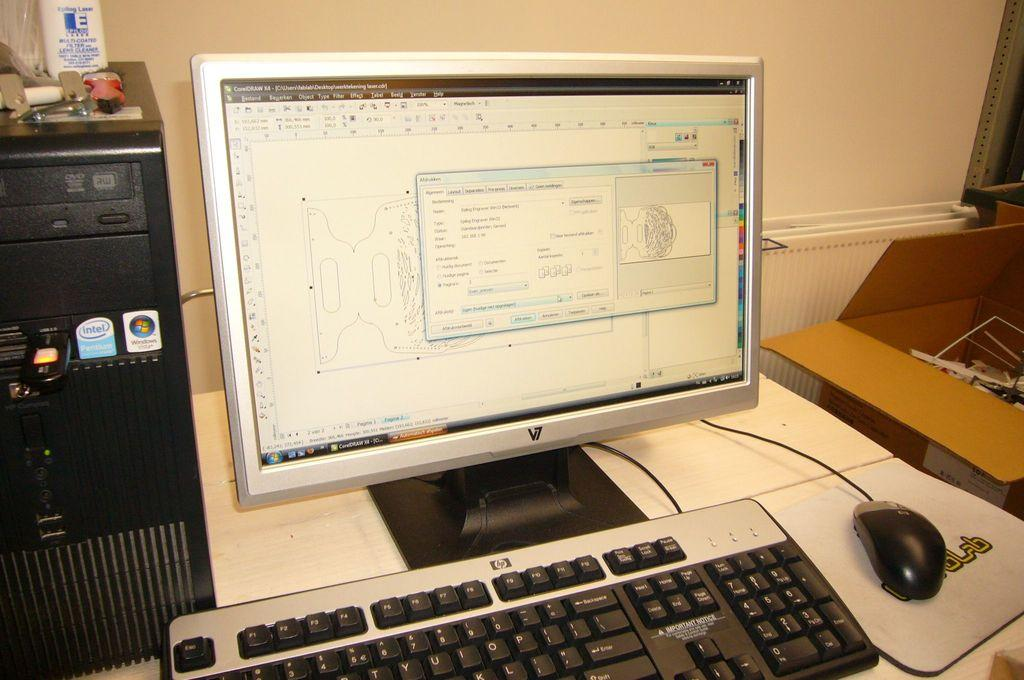<image>
Describe the image concisely. An HP keyboard and mouse sitting in front of a computer screen that is on. 